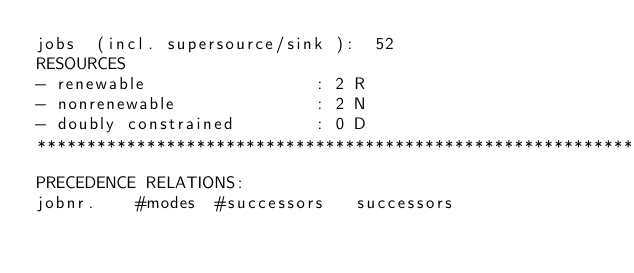<code> <loc_0><loc_0><loc_500><loc_500><_ObjectiveC_>jobs  (incl. supersource/sink ):	52
RESOURCES
- renewable                 : 2 R
- nonrenewable              : 2 N
- doubly constrained        : 0 D
************************************************************************
PRECEDENCE RELATIONS:
jobnr.    #modes  #successors   successors</code> 